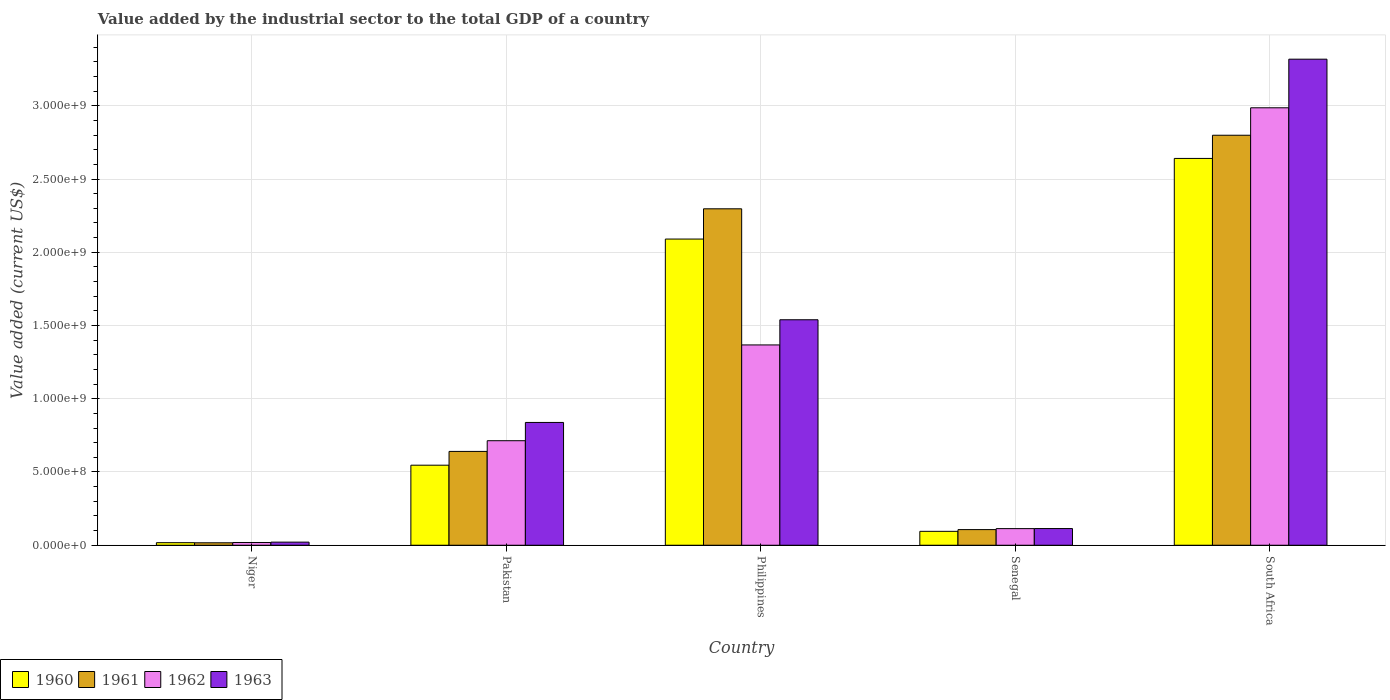How many groups of bars are there?
Give a very brief answer. 5. Are the number of bars per tick equal to the number of legend labels?
Offer a terse response. Yes. Are the number of bars on each tick of the X-axis equal?
Provide a succinct answer. Yes. What is the label of the 1st group of bars from the left?
Offer a terse response. Niger. What is the value added by the industrial sector to the total GDP in 1961 in South Africa?
Keep it short and to the point. 2.80e+09. Across all countries, what is the maximum value added by the industrial sector to the total GDP in 1961?
Offer a very short reply. 2.80e+09. Across all countries, what is the minimum value added by the industrial sector to the total GDP in 1960?
Offer a very short reply. 1.75e+07. In which country was the value added by the industrial sector to the total GDP in 1963 maximum?
Provide a succinct answer. South Africa. In which country was the value added by the industrial sector to the total GDP in 1962 minimum?
Offer a terse response. Niger. What is the total value added by the industrial sector to the total GDP in 1961 in the graph?
Provide a succinct answer. 5.86e+09. What is the difference between the value added by the industrial sector to the total GDP in 1960 in Philippines and that in Senegal?
Your response must be concise. 2.00e+09. What is the difference between the value added by the industrial sector to the total GDP in 1963 in Niger and the value added by the industrial sector to the total GDP in 1960 in Senegal?
Keep it short and to the point. -7.37e+07. What is the average value added by the industrial sector to the total GDP in 1963 per country?
Provide a succinct answer. 1.17e+09. What is the difference between the value added by the industrial sector to the total GDP of/in 1962 and value added by the industrial sector to the total GDP of/in 1960 in Senegal?
Offer a terse response. 1.86e+07. What is the ratio of the value added by the industrial sector to the total GDP in 1963 in Pakistan to that in Senegal?
Offer a very short reply. 7.36. What is the difference between the highest and the second highest value added by the industrial sector to the total GDP in 1962?
Provide a short and direct response. -6.54e+08. What is the difference between the highest and the lowest value added by the industrial sector to the total GDP in 1960?
Your answer should be compact. 2.62e+09. What does the 2nd bar from the left in Pakistan represents?
Provide a short and direct response. 1961. Are the values on the major ticks of Y-axis written in scientific E-notation?
Your answer should be compact. Yes. Does the graph contain any zero values?
Keep it short and to the point. No. Does the graph contain grids?
Give a very brief answer. Yes. Where does the legend appear in the graph?
Provide a succinct answer. Bottom left. What is the title of the graph?
Offer a terse response. Value added by the industrial sector to the total GDP of a country. What is the label or title of the X-axis?
Your answer should be compact. Country. What is the label or title of the Y-axis?
Your answer should be very brief. Value added (current US$). What is the Value added (current US$) in 1960 in Niger?
Your response must be concise. 1.75e+07. What is the Value added (current US$) in 1961 in Niger?
Your response must be concise. 1.67e+07. What is the Value added (current US$) in 1962 in Niger?
Offer a very short reply. 1.87e+07. What is the Value added (current US$) in 1963 in Niger?
Your answer should be compact. 2.12e+07. What is the Value added (current US$) of 1960 in Pakistan?
Give a very brief answer. 5.46e+08. What is the Value added (current US$) of 1961 in Pakistan?
Ensure brevity in your answer.  6.40e+08. What is the Value added (current US$) of 1962 in Pakistan?
Your answer should be compact. 7.14e+08. What is the Value added (current US$) in 1963 in Pakistan?
Offer a terse response. 8.38e+08. What is the Value added (current US$) in 1960 in Philippines?
Give a very brief answer. 2.09e+09. What is the Value added (current US$) of 1961 in Philippines?
Make the answer very short. 2.30e+09. What is the Value added (current US$) in 1962 in Philippines?
Provide a short and direct response. 1.37e+09. What is the Value added (current US$) in 1963 in Philippines?
Your answer should be very brief. 1.54e+09. What is the Value added (current US$) in 1960 in Senegal?
Provide a short and direct response. 9.49e+07. What is the Value added (current US$) in 1961 in Senegal?
Offer a terse response. 1.07e+08. What is the Value added (current US$) of 1962 in Senegal?
Ensure brevity in your answer.  1.13e+08. What is the Value added (current US$) in 1963 in Senegal?
Offer a terse response. 1.14e+08. What is the Value added (current US$) of 1960 in South Africa?
Give a very brief answer. 2.64e+09. What is the Value added (current US$) in 1961 in South Africa?
Offer a very short reply. 2.80e+09. What is the Value added (current US$) of 1962 in South Africa?
Provide a succinct answer. 2.99e+09. What is the Value added (current US$) in 1963 in South Africa?
Your answer should be compact. 3.32e+09. Across all countries, what is the maximum Value added (current US$) of 1960?
Your answer should be compact. 2.64e+09. Across all countries, what is the maximum Value added (current US$) in 1961?
Your answer should be compact. 2.80e+09. Across all countries, what is the maximum Value added (current US$) in 1962?
Keep it short and to the point. 2.99e+09. Across all countries, what is the maximum Value added (current US$) in 1963?
Your answer should be compact. 3.32e+09. Across all countries, what is the minimum Value added (current US$) of 1960?
Make the answer very short. 1.75e+07. Across all countries, what is the minimum Value added (current US$) in 1961?
Offer a terse response. 1.67e+07. Across all countries, what is the minimum Value added (current US$) of 1962?
Make the answer very short. 1.87e+07. Across all countries, what is the minimum Value added (current US$) of 1963?
Provide a succinct answer. 2.12e+07. What is the total Value added (current US$) of 1960 in the graph?
Your answer should be very brief. 5.39e+09. What is the total Value added (current US$) in 1961 in the graph?
Your answer should be compact. 5.86e+09. What is the total Value added (current US$) in 1962 in the graph?
Give a very brief answer. 5.20e+09. What is the total Value added (current US$) of 1963 in the graph?
Make the answer very short. 5.83e+09. What is the difference between the Value added (current US$) of 1960 in Niger and that in Pakistan?
Provide a succinct answer. -5.29e+08. What is the difference between the Value added (current US$) of 1961 in Niger and that in Pakistan?
Provide a succinct answer. -6.24e+08. What is the difference between the Value added (current US$) in 1962 in Niger and that in Pakistan?
Your response must be concise. -6.95e+08. What is the difference between the Value added (current US$) in 1963 in Niger and that in Pakistan?
Provide a short and direct response. -8.17e+08. What is the difference between the Value added (current US$) in 1960 in Niger and that in Philippines?
Offer a very short reply. -2.07e+09. What is the difference between the Value added (current US$) in 1961 in Niger and that in Philippines?
Your response must be concise. -2.28e+09. What is the difference between the Value added (current US$) of 1962 in Niger and that in Philippines?
Your response must be concise. -1.35e+09. What is the difference between the Value added (current US$) of 1963 in Niger and that in Philippines?
Provide a short and direct response. -1.52e+09. What is the difference between the Value added (current US$) in 1960 in Niger and that in Senegal?
Your answer should be very brief. -7.74e+07. What is the difference between the Value added (current US$) of 1961 in Niger and that in Senegal?
Your response must be concise. -9.00e+07. What is the difference between the Value added (current US$) of 1962 in Niger and that in Senegal?
Offer a very short reply. -9.48e+07. What is the difference between the Value added (current US$) of 1963 in Niger and that in Senegal?
Make the answer very short. -9.27e+07. What is the difference between the Value added (current US$) in 1960 in Niger and that in South Africa?
Provide a short and direct response. -2.62e+09. What is the difference between the Value added (current US$) in 1961 in Niger and that in South Africa?
Keep it short and to the point. -2.78e+09. What is the difference between the Value added (current US$) of 1962 in Niger and that in South Africa?
Keep it short and to the point. -2.97e+09. What is the difference between the Value added (current US$) of 1963 in Niger and that in South Africa?
Your answer should be compact. -3.30e+09. What is the difference between the Value added (current US$) of 1960 in Pakistan and that in Philippines?
Keep it short and to the point. -1.54e+09. What is the difference between the Value added (current US$) of 1961 in Pakistan and that in Philippines?
Provide a short and direct response. -1.66e+09. What is the difference between the Value added (current US$) of 1962 in Pakistan and that in Philippines?
Offer a terse response. -6.54e+08. What is the difference between the Value added (current US$) in 1963 in Pakistan and that in Philippines?
Your response must be concise. -7.01e+08. What is the difference between the Value added (current US$) in 1960 in Pakistan and that in Senegal?
Offer a terse response. 4.52e+08. What is the difference between the Value added (current US$) in 1961 in Pakistan and that in Senegal?
Your answer should be very brief. 5.34e+08. What is the difference between the Value added (current US$) of 1962 in Pakistan and that in Senegal?
Ensure brevity in your answer.  6.00e+08. What is the difference between the Value added (current US$) in 1963 in Pakistan and that in Senegal?
Offer a very short reply. 7.24e+08. What is the difference between the Value added (current US$) of 1960 in Pakistan and that in South Africa?
Your answer should be compact. -2.09e+09. What is the difference between the Value added (current US$) of 1961 in Pakistan and that in South Africa?
Make the answer very short. -2.16e+09. What is the difference between the Value added (current US$) of 1962 in Pakistan and that in South Africa?
Your answer should be very brief. -2.27e+09. What is the difference between the Value added (current US$) in 1963 in Pakistan and that in South Africa?
Provide a short and direct response. -2.48e+09. What is the difference between the Value added (current US$) of 1960 in Philippines and that in Senegal?
Your answer should be compact. 2.00e+09. What is the difference between the Value added (current US$) of 1961 in Philippines and that in Senegal?
Your answer should be very brief. 2.19e+09. What is the difference between the Value added (current US$) in 1962 in Philippines and that in Senegal?
Make the answer very short. 1.25e+09. What is the difference between the Value added (current US$) of 1963 in Philippines and that in Senegal?
Your response must be concise. 1.43e+09. What is the difference between the Value added (current US$) of 1960 in Philippines and that in South Africa?
Provide a succinct answer. -5.50e+08. What is the difference between the Value added (current US$) of 1961 in Philippines and that in South Africa?
Provide a short and direct response. -5.02e+08. What is the difference between the Value added (current US$) of 1962 in Philippines and that in South Africa?
Your response must be concise. -1.62e+09. What is the difference between the Value added (current US$) in 1963 in Philippines and that in South Africa?
Your response must be concise. -1.78e+09. What is the difference between the Value added (current US$) of 1960 in Senegal and that in South Africa?
Ensure brevity in your answer.  -2.55e+09. What is the difference between the Value added (current US$) of 1961 in Senegal and that in South Africa?
Provide a short and direct response. -2.69e+09. What is the difference between the Value added (current US$) in 1962 in Senegal and that in South Africa?
Provide a short and direct response. -2.87e+09. What is the difference between the Value added (current US$) of 1963 in Senegal and that in South Africa?
Provide a short and direct response. -3.20e+09. What is the difference between the Value added (current US$) of 1960 in Niger and the Value added (current US$) of 1961 in Pakistan?
Offer a terse response. -6.23e+08. What is the difference between the Value added (current US$) in 1960 in Niger and the Value added (current US$) in 1962 in Pakistan?
Your answer should be compact. -6.96e+08. What is the difference between the Value added (current US$) of 1960 in Niger and the Value added (current US$) of 1963 in Pakistan?
Ensure brevity in your answer.  -8.21e+08. What is the difference between the Value added (current US$) in 1961 in Niger and the Value added (current US$) in 1962 in Pakistan?
Make the answer very short. -6.97e+08. What is the difference between the Value added (current US$) in 1961 in Niger and the Value added (current US$) in 1963 in Pakistan?
Your answer should be very brief. -8.22e+08. What is the difference between the Value added (current US$) of 1962 in Niger and the Value added (current US$) of 1963 in Pakistan?
Your answer should be very brief. -8.20e+08. What is the difference between the Value added (current US$) in 1960 in Niger and the Value added (current US$) in 1961 in Philippines?
Ensure brevity in your answer.  -2.28e+09. What is the difference between the Value added (current US$) in 1960 in Niger and the Value added (current US$) in 1962 in Philippines?
Ensure brevity in your answer.  -1.35e+09. What is the difference between the Value added (current US$) in 1960 in Niger and the Value added (current US$) in 1963 in Philippines?
Make the answer very short. -1.52e+09. What is the difference between the Value added (current US$) in 1961 in Niger and the Value added (current US$) in 1962 in Philippines?
Make the answer very short. -1.35e+09. What is the difference between the Value added (current US$) in 1961 in Niger and the Value added (current US$) in 1963 in Philippines?
Ensure brevity in your answer.  -1.52e+09. What is the difference between the Value added (current US$) in 1962 in Niger and the Value added (current US$) in 1963 in Philippines?
Provide a succinct answer. -1.52e+09. What is the difference between the Value added (current US$) in 1960 in Niger and the Value added (current US$) in 1961 in Senegal?
Make the answer very short. -8.93e+07. What is the difference between the Value added (current US$) in 1960 in Niger and the Value added (current US$) in 1962 in Senegal?
Ensure brevity in your answer.  -9.60e+07. What is the difference between the Value added (current US$) in 1960 in Niger and the Value added (current US$) in 1963 in Senegal?
Your answer should be very brief. -9.65e+07. What is the difference between the Value added (current US$) in 1961 in Niger and the Value added (current US$) in 1962 in Senegal?
Your answer should be very brief. -9.67e+07. What is the difference between the Value added (current US$) in 1961 in Niger and the Value added (current US$) in 1963 in Senegal?
Ensure brevity in your answer.  -9.72e+07. What is the difference between the Value added (current US$) of 1962 in Niger and the Value added (current US$) of 1963 in Senegal?
Your answer should be compact. -9.52e+07. What is the difference between the Value added (current US$) of 1960 in Niger and the Value added (current US$) of 1961 in South Africa?
Give a very brief answer. -2.78e+09. What is the difference between the Value added (current US$) in 1960 in Niger and the Value added (current US$) in 1962 in South Africa?
Make the answer very short. -2.97e+09. What is the difference between the Value added (current US$) in 1960 in Niger and the Value added (current US$) in 1963 in South Africa?
Your answer should be compact. -3.30e+09. What is the difference between the Value added (current US$) in 1961 in Niger and the Value added (current US$) in 1962 in South Africa?
Make the answer very short. -2.97e+09. What is the difference between the Value added (current US$) of 1961 in Niger and the Value added (current US$) of 1963 in South Africa?
Your answer should be very brief. -3.30e+09. What is the difference between the Value added (current US$) in 1962 in Niger and the Value added (current US$) in 1963 in South Africa?
Provide a short and direct response. -3.30e+09. What is the difference between the Value added (current US$) in 1960 in Pakistan and the Value added (current US$) in 1961 in Philippines?
Ensure brevity in your answer.  -1.75e+09. What is the difference between the Value added (current US$) of 1960 in Pakistan and the Value added (current US$) of 1962 in Philippines?
Provide a short and direct response. -8.21e+08. What is the difference between the Value added (current US$) in 1960 in Pakistan and the Value added (current US$) in 1963 in Philippines?
Your answer should be very brief. -9.93e+08. What is the difference between the Value added (current US$) of 1961 in Pakistan and the Value added (current US$) of 1962 in Philippines?
Make the answer very short. -7.27e+08. What is the difference between the Value added (current US$) of 1961 in Pakistan and the Value added (current US$) of 1963 in Philippines?
Give a very brief answer. -8.99e+08. What is the difference between the Value added (current US$) in 1962 in Pakistan and the Value added (current US$) in 1963 in Philippines?
Make the answer very short. -8.26e+08. What is the difference between the Value added (current US$) in 1960 in Pakistan and the Value added (current US$) in 1961 in Senegal?
Ensure brevity in your answer.  4.40e+08. What is the difference between the Value added (current US$) in 1960 in Pakistan and the Value added (current US$) in 1962 in Senegal?
Make the answer very short. 4.33e+08. What is the difference between the Value added (current US$) in 1960 in Pakistan and the Value added (current US$) in 1963 in Senegal?
Your answer should be very brief. 4.32e+08. What is the difference between the Value added (current US$) in 1961 in Pakistan and the Value added (current US$) in 1962 in Senegal?
Offer a very short reply. 5.27e+08. What is the difference between the Value added (current US$) of 1961 in Pakistan and the Value added (current US$) of 1963 in Senegal?
Keep it short and to the point. 5.27e+08. What is the difference between the Value added (current US$) of 1962 in Pakistan and the Value added (current US$) of 1963 in Senegal?
Make the answer very short. 6.00e+08. What is the difference between the Value added (current US$) of 1960 in Pakistan and the Value added (current US$) of 1961 in South Africa?
Offer a very short reply. -2.25e+09. What is the difference between the Value added (current US$) in 1960 in Pakistan and the Value added (current US$) in 1962 in South Africa?
Your answer should be compact. -2.44e+09. What is the difference between the Value added (current US$) in 1960 in Pakistan and the Value added (current US$) in 1963 in South Africa?
Provide a short and direct response. -2.77e+09. What is the difference between the Value added (current US$) in 1961 in Pakistan and the Value added (current US$) in 1962 in South Africa?
Make the answer very short. -2.35e+09. What is the difference between the Value added (current US$) in 1961 in Pakistan and the Value added (current US$) in 1963 in South Africa?
Provide a succinct answer. -2.68e+09. What is the difference between the Value added (current US$) in 1962 in Pakistan and the Value added (current US$) in 1963 in South Africa?
Keep it short and to the point. -2.60e+09. What is the difference between the Value added (current US$) in 1960 in Philippines and the Value added (current US$) in 1961 in Senegal?
Provide a short and direct response. 1.98e+09. What is the difference between the Value added (current US$) in 1960 in Philippines and the Value added (current US$) in 1962 in Senegal?
Your answer should be compact. 1.98e+09. What is the difference between the Value added (current US$) of 1960 in Philippines and the Value added (current US$) of 1963 in Senegal?
Keep it short and to the point. 1.98e+09. What is the difference between the Value added (current US$) of 1961 in Philippines and the Value added (current US$) of 1962 in Senegal?
Ensure brevity in your answer.  2.18e+09. What is the difference between the Value added (current US$) of 1961 in Philippines and the Value added (current US$) of 1963 in Senegal?
Offer a terse response. 2.18e+09. What is the difference between the Value added (current US$) in 1962 in Philippines and the Value added (current US$) in 1963 in Senegal?
Offer a terse response. 1.25e+09. What is the difference between the Value added (current US$) in 1960 in Philippines and the Value added (current US$) in 1961 in South Africa?
Provide a succinct answer. -7.09e+08. What is the difference between the Value added (current US$) of 1960 in Philippines and the Value added (current US$) of 1962 in South Africa?
Offer a terse response. -8.96e+08. What is the difference between the Value added (current US$) of 1960 in Philippines and the Value added (current US$) of 1963 in South Africa?
Your answer should be very brief. -1.23e+09. What is the difference between the Value added (current US$) in 1961 in Philippines and the Value added (current US$) in 1962 in South Africa?
Provide a succinct answer. -6.90e+08. What is the difference between the Value added (current US$) of 1961 in Philippines and the Value added (current US$) of 1963 in South Africa?
Offer a very short reply. -1.02e+09. What is the difference between the Value added (current US$) in 1962 in Philippines and the Value added (current US$) in 1963 in South Africa?
Your response must be concise. -1.95e+09. What is the difference between the Value added (current US$) of 1960 in Senegal and the Value added (current US$) of 1961 in South Africa?
Keep it short and to the point. -2.70e+09. What is the difference between the Value added (current US$) in 1960 in Senegal and the Value added (current US$) in 1962 in South Africa?
Your answer should be very brief. -2.89e+09. What is the difference between the Value added (current US$) of 1960 in Senegal and the Value added (current US$) of 1963 in South Africa?
Provide a short and direct response. -3.22e+09. What is the difference between the Value added (current US$) of 1961 in Senegal and the Value added (current US$) of 1962 in South Africa?
Provide a succinct answer. -2.88e+09. What is the difference between the Value added (current US$) in 1961 in Senegal and the Value added (current US$) in 1963 in South Africa?
Keep it short and to the point. -3.21e+09. What is the difference between the Value added (current US$) in 1962 in Senegal and the Value added (current US$) in 1963 in South Africa?
Provide a short and direct response. -3.20e+09. What is the average Value added (current US$) in 1960 per country?
Make the answer very short. 1.08e+09. What is the average Value added (current US$) of 1961 per country?
Offer a terse response. 1.17e+09. What is the average Value added (current US$) in 1962 per country?
Keep it short and to the point. 1.04e+09. What is the average Value added (current US$) in 1963 per country?
Offer a very short reply. 1.17e+09. What is the difference between the Value added (current US$) in 1960 and Value added (current US$) in 1961 in Niger?
Provide a short and direct response. 7.26e+05. What is the difference between the Value added (current US$) of 1960 and Value added (current US$) of 1962 in Niger?
Ensure brevity in your answer.  -1.25e+06. What is the difference between the Value added (current US$) in 1960 and Value added (current US$) in 1963 in Niger?
Offer a terse response. -3.72e+06. What is the difference between the Value added (current US$) in 1961 and Value added (current US$) in 1962 in Niger?
Your answer should be compact. -1.97e+06. What is the difference between the Value added (current US$) of 1961 and Value added (current US$) of 1963 in Niger?
Your answer should be very brief. -4.44e+06. What is the difference between the Value added (current US$) in 1962 and Value added (current US$) in 1963 in Niger?
Your answer should be compact. -2.47e+06. What is the difference between the Value added (current US$) of 1960 and Value added (current US$) of 1961 in Pakistan?
Your answer should be compact. -9.41e+07. What is the difference between the Value added (current US$) of 1960 and Value added (current US$) of 1962 in Pakistan?
Offer a very short reply. -1.67e+08. What is the difference between the Value added (current US$) in 1960 and Value added (current US$) in 1963 in Pakistan?
Ensure brevity in your answer.  -2.92e+08. What is the difference between the Value added (current US$) of 1961 and Value added (current US$) of 1962 in Pakistan?
Keep it short and to the point. -7.31e+07. What is the difference between the Value added (current US$) in 1961 and Value added (current US$) in 1963 in Pakistan?
Ensure brevity in your answer.  -1.98e+08. What is the difference between the Value added (current US$) in 1962 and Value added (current US$) in 1963 in Pakistan?
Your answer should be very brief. -1.25e+08. What is the difference between the Value added (current US$) in 1960 and Value added (current US$) in 1961 in Philippines?
Provide a short and direct response. -2.07e+08. What is the difference between the Value added (current US$) of 1960 and Value added (current US$) of 1962 in Philippines?
Offer a terse response. 7.23e+08. What is the difference between the Value added (current US$) in 1960 and Value added (current US$) in 1963 in Philippines?
Ensure brevity in your answer.  5.51e+08. What is the difference between the Value added (current US$) of 1961 and Value added (current US$) of 1962 in Philippines?
Provide a succinct answer. 9.29e+08. What is the difference between the Value added (current US$) in 1961 and Value added (current US$) in 1963 in Philippines?
Your answer should be very brief. 7.57e+08. What is the difference between the Value added (current US$) of 1962 and Value added (current US$) of 1963 in Philippines?
Provide a short and direct response. -1.72e+08. What is the difference between the Value added (current US$) of 1960 and Value added (current US$) of 1961 in Senegal?
Your answer should be compact. -1.19e+07. What is the difference between the Value added (current US$) in 1960 and Value added (current US$) in 1962 in Senegal?
Your response must be concise. -1.86e+07. What is the difference between the Value added (current US$) of 1960 and Value added (current US$) of 1963 in Senegal?
Your answer should be very brief. -1.91e+07. What is the difference between the Value added (current US$) of 1961 and Value added (current US$) of 1962 in Senegal?
Offer a very short reply. -6.73e+06. What is the difference between the Value added (current US$) of 1961 and Value added (current US$) of 1963 in Senegal?
Offer a terse response. -7.17e+06. What is the difference between the Value added (current US$) in 1962 and Value added (current US$) in 1963 in Senegal?
Give a very brief answer. -4.40e+05. What is the difference between the Value added (current US$) in 1960 and Value added (current US$) in 1961 in South Africa?
Make the answer very short. -1.58e+08. What is the difference between the Value added (current US$) of 1960 and Value added (current US$) of 1962 in South Africa?
Your response must be concise. -3.46e+08. What is the difference between the Value added (current US$) in 1960 and Value added (current US$) in 1963 in South Africa?
Offer a terse response. -6.78e+08. What is the difference between the Value added (current US$) in 1961 and Value added (current US$) in 1962 in South Africa?
Ensure brevity in your answer.  -1.87e+08. What is the difference between the Value added (current US$) of 1961 and Value added (current US$) of 1963 in South Africa?
Provide a succinct answer. -5.19e+08. What is the difference between the Value added (current US$) of 1962 and Value added (current US$) of 1963 in South Africa?
Offer a very short reply. -3.32e+08. What is the ratio of the Value added (current US$) of 1960 in Niger to that in Pakistan?
Keep it short and to the point. 0.03. What is the ratio of the Value added (current US$) of 1961 in Niger to that in Pakistan?
Offer a terse response. 0.03. What is the ratio of the Value added (current US$) of 1962 in Niger to that in Pakistan?
Provide a succinct answer. 0.03. What is the ratio of the Value added (current US$) in 1963 in Niger to that in Pakistan?
Your response must be concise. 0.03. What is the ratio of the Value added (current US$) in 1960 in Niger to that in Philippines?
Provide a short and direct response. 0.01. What is the ratio of the Value added (current US$) in 1961 in Niger to that in Philippines?
Keep it short and to the point. 0.01. What is the ratio of the Value added (current US$) in 1962 in Niger to that in Philippines?
Your response must be concise. 0.01. What is the ratio of the Value added (current US$) of 1963 in Niger to that in Philippines?
Ensure brevity in your answer.  0.01. What is the ratio of the Value added (current US$) of 1960 in Niger to that in Senegal?
Offer a very short reply. 0.18. What is the ratio of the Value added (current US$) in 1961 in Niger to that in Senegal?
Your answer should be compact. 0.16. What is the ratio of the Value added (current US$) of 1962 in Niger to that in Senegal?
Give a very brief answer. 0.16. What is the ratio of the Value added (current US$) of 1963 in Niger to that in Senegal?
Give a very brief answer. 0.19. What is the ratio of the Value added (current US$) of 1960 in Niger to that in South Africa?
Ensure brevity in your answer.  0.01. What is the ratio of the Value added (current US$) in 1961 in Niger to that in South Africa?
Offer a terse response. 0.01. What is the ratio of the Value added (current US$) of 1962 in Niger to that in South Africa?
Provide a succinct answer. 0.01. What is the ratio of the Value added (current US$) in 1963 in Niger to that in South Africa?
Offer a very short reply. 0.01. What is the ratio of the Value added (current US$) in 1960 in Pakistan to that in Philippines?
Offer a very short reply. 0.26. What is the ratio of the Value added (current US$) in 1961 in Pakistan to that in Philippines?
Your answer should be compact. 0.28. What is the ratio of the Value added (current US$) in 1962 in Pakistan to that in Philippines?
Your response must be concise. 0.52. What is the ratio of the Value added (current US$) of 1963 in Pakistan to that in Philippines?
Offer a terse response. 0.54. What is the ratio of the Value added (current US$) in 1960 in Pakistan to that in Senegal?
Provide a short and direct response. 5.76. What is the ratio of the Value added (current US$) of 1961 in Pakistan to that in Senegal?
Your answer should be compact. 6. What is the ratio of the Value added (current US$) in 1962 in Pakistan to that in Senegal?
Offer a very short reply. 6.29. What is the ratio of the Value added (current US$) in 1963 in Pakistan to that in Senegal?
Provide a succinct answer. 7.36. What is the ratio of the Value added (current US$) of 1960 in Pakistan to that in South Africa?
Offer a very short reply. 0.21. What is the ratio of the Value added (current US$) of 1961 in Pakistan to that in South Africa?
Offer a very short reply. 0.23. What is the ratio of the Value added (current US$) of 1962 in Pakistan to that in South Africa?
Offer a very short reply. 0.24. What is the ratio of the Value added (current US$) of 1963 in Pakistan to that in South Africa?
Make the answer very short. 0.25. What is the ratio of the Value added (current US$) of 1960 in Philippines to that in Senegal?
Your response must be concise. 22.03. What is the ratio of the Value added (current US$) in 1961 in Philippines to that in Senegal?
Offer a very short reply. 21.51. What is the ratio of the Value added (current US$) in 1962 in Philippines to that in Senegal?
Offer a terse response. 12.05. What is the ratio of the Value added (current US$) in 1963 in Philippines to that in Senegal?
Provide a succinct answer. 13.51. What is the ratio of the Value added (current US$) of 1960 in Philippines to that in South Africa?
Offer a very short reply. 0.79. What is the ratio of the Value added (current US$) in 1961 in Philippines to that in South Africa?
Ensure brevity in your answer.  0.82. What is the ratio of the Value added (current US$) of 1962 in Philippines to that in South Africa?
Provide a succinct answer. 0.46. What is the ratio of the Value added (current US$) of 1963 in Philippines to that in South Africa?
Keep it short and to the point. 0.46. What is the ratio of the Value added (current US$) in 1960 in Senegal to that in South Africa?
Your answer should be very brief. 0.04. What is the ratio of the Value added (current US$) in 1961 in Senegal to that in South Africa?
Offer a terse response. 0.04. What is the ratio of the Value added (current US$) in 1962 in Senegal to that in South Africa?
Your response must be concise. 0.04. What is the ratio of the Value added (current US$) in 1963 in Senegal to that in South Africa?
Your answer should be compact. 0.03. What is the difference between the highest and the second highest Value added (current US$) in 1960?
Your response must be concise. 5.50e+08. What is the difference between the highest and the second highest Value added (current US$) in 1961?
Your answer should be very brief. 5.02e+08. What is the difference between the highest and the second highest Value added (current US$) of 1962?
Your answer should be very brief. 1.62e+09. What is the difference between the highest and the second highest Value added (current US$) in 1963?
Offer a very short reply. 1.78e+09. What is the difference between the highest and the lowest Value added (current US$) of 1960?
Provide a succinct answer. 2.62e+09. What is the difference between the highest and the lowest Value added (current US$) of 1961?
Offer a very short reply. 2.78e+09. What is the difference between the highest and the lowest Value added (current US$) of 1962?
Ensure brevity in your answer.  2.97e+09. What is the difference between the highest and the lowest Value added (current US$) in 1963?
Provide a short and direct response. 3.30e+09. 